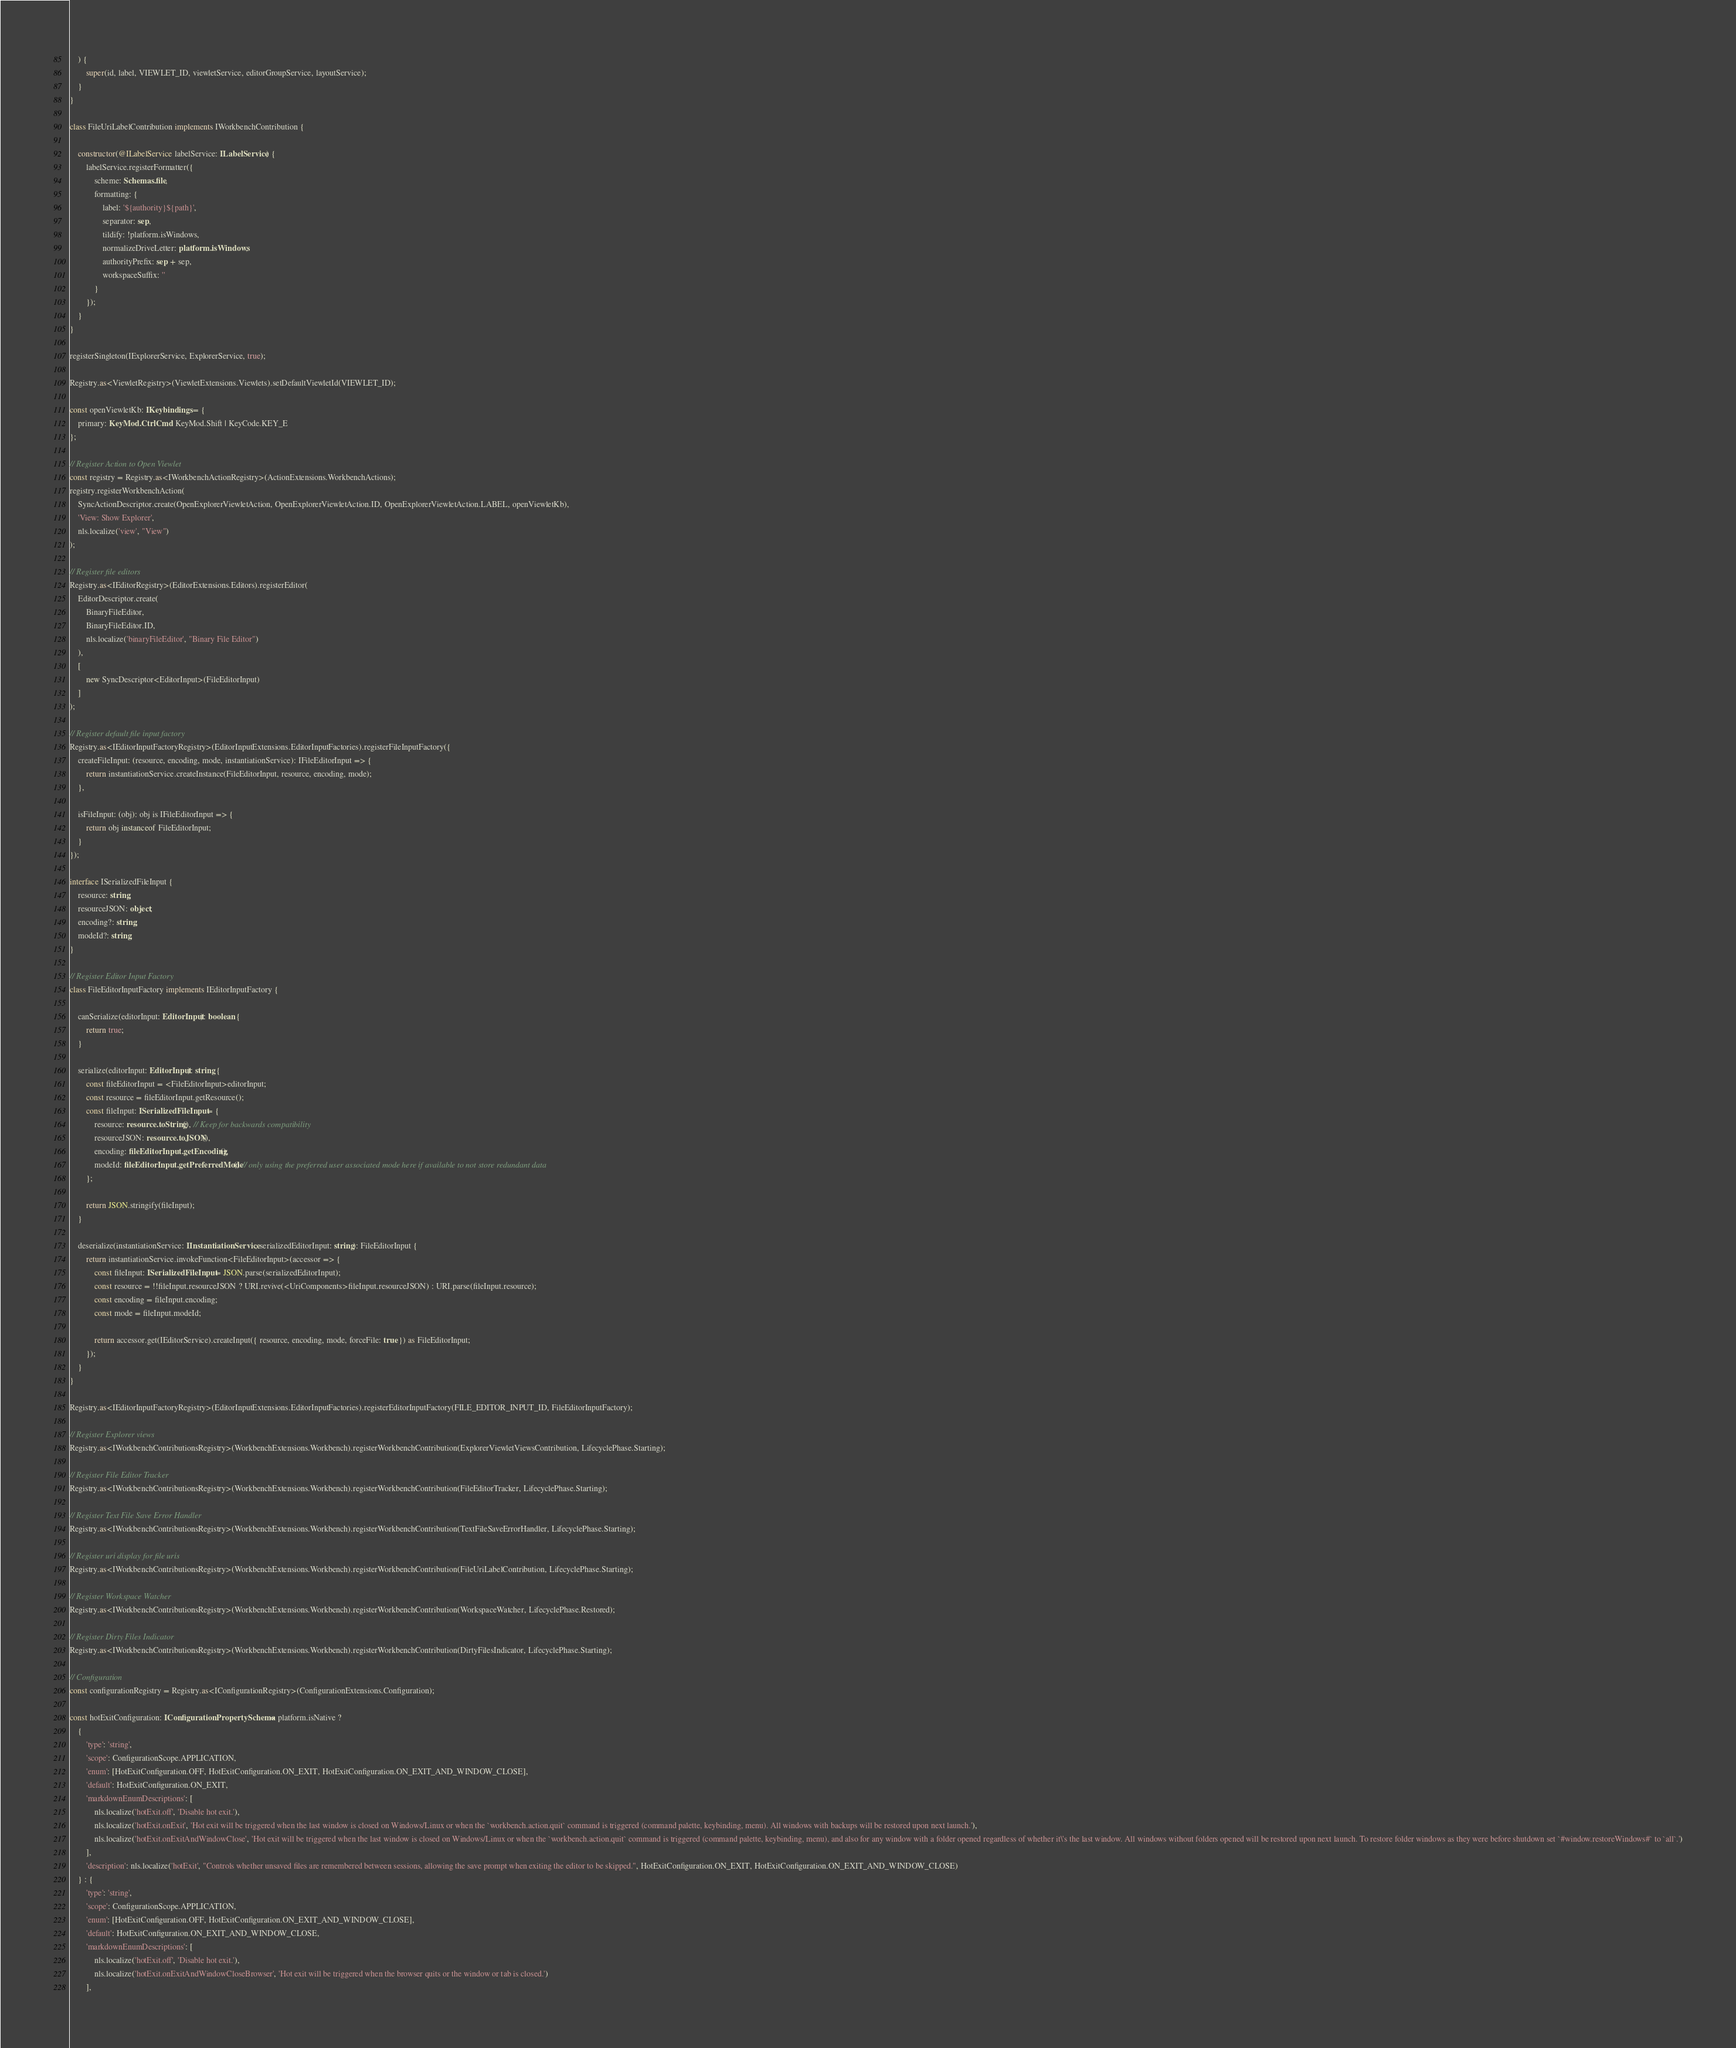Convert code to text. <code><loc_0><loc_0><loc_500><loc_500><_TypeScript_>	) {
		super(id, label, VIEWLET_ID, viewletService, editorGroupService, layoutService);
	}
}

class FileUriLabelContribution implements IWorkbenchContribution {

	constructor(@ILabelService labelService: ILabelService) {
		labelService.registerFormatter({
			scheme: Schemas.file,
			formatting: {
				label: '${authority}${path}',
				separator: sep,
				tildify: !platform.isWindows,
				normalizeDriveLetter: platform.isWindows,
				authorityPrefix: sep + sep,
				workspaceSuffix: ''
			}
		});
	}
}

registerSingleton(IExplorerService, ExplorerService, true);

Registry.as<ViewletRegistry>(ViewletExtensions.Viewlets).setDefaultViewletId(VIEWLET_ID);

const openViewletKb: IKeybindings = {
	primary: KeyMod.CtrlCmd | KeyMod.Shift | KeyCode.KEY_E
};

// Register Action to Open Viewlet
const registry = Registry.as<IWorkbenchActionRegistry>(ActionExtensions.WorkbenchActions);
registry.registerWorkbenchAction(
	SyncActionDescriptor.create(OpenExplorerViewletAction, OpenExplorerViewletAction.ID, OpenExplorerViewletAction.LABEL, openViewletKb),
	'View: Show Explorer',
	nls.localize('view', "View")
);

// Register file editors
Registry.as<IEditorRegistry>(EditorExtensions.Editors).registerEditor(
	EditorDescriptor.create(
		BinaryFileEditor,
		BinaryFileEditor.ID,
		nls.localize('binaryFileEditor', "Binary File Editor")
	),
	[
		new SyncDescriptor<EditorInput>(FileEditorInput)
	]
);

// Register default file input factory
Registry.as<IEditorInputFactoryRegistry>(EditorInputExtensions.EditorInputFactories).registerFileInputFactory({
	createFileInput: (resource, encoding, mode, instantiationService): IFileEditorInput => {
		return instantiationService.createInstance(FileEditorInput, resource, encoding, mode);
	},

	isFileInput: (obj): obj is IFileEditorInput => {
		return obj instanceof FileEditorInput;
	}
});

interface ISerializedFileInput {
	resource: string;
	resourceJSON: object;
	encoding?: string;
	modeId?: string;
}

// Register Editor Input Factory
class FileEditorInputFactory implements IEditorInputFactory {

	canSerialize(editorInput: EditorInput): boolean {
		return true;
	}

	serialize(editorInput: EditorInput): string {
		const fileEditorInput = <FileEditorInput>editorInput;
		const resource = fileEditorInput.getResource();
		const fileInput: ISerializedFileInput = {
			resource: resource.toString(), // Keep for backwards compatibility
			resourceJSON: resource.toJSON(),
			encoding: fileEditorInput.getEncoding(),
			modeId: fileEditorInput.getPreferredMode() // only using the preferred user associated mode here if available to not store redundant data
		};

		return JSON.stringify(fileInput);
	}

	deserialize(instantiationService: IInstantiationService, serializedEditorInput: string): FileEditorInput {
		return instantiationService.invokeFunction<FileEditorInput>(accessor => {
			const fileInput: ISerializedFileInput = JSON.parse(serializedEditorInput);
			const resource = !!fileInput.resourceJSON ? URI.revive(<UriComponents>fileInput.resourceJSON) : URI.parse(fileInput.resource);
			const encoding = fileInput.encoding;
			const mode = fileInput.modeId;

			return accessor.get(IEditorService).createInput({ resource, encoding, mode, forceFile: true }) as FileEditorInput;
		});
	}
}

Registry.as<IEditorInputFactoryRegistry>(EditorInputExtensions.EditorInputFactories).registerEditorInputFactory(FILE_EDITOR_INPUT_ID, FileEditorInputFactory);

// Register Explorer views
Registry.as<IWorkbenchContributionsRegistry>(WorkbenchExtensions.Workbench).registerWorkbenchContribution(ExplorerViewletViewsContribution, LifecyclePhase.Starting);

// Register File Editor Tracker
Registry.as<IWorkbenchContributionsRegistry>(WorkbenchExtensions.Workbench).registerWorkbenchContribution(FileEditorTracker, LifecyclePhase.Starting);

// Register Text File Save Error Handler
Registry.as<IWorkbenchContributionsRegistry>(WorkbenchExtensions.Workbench).registerWorkbenchContribution(TextFileSaveErrorHandler, LifecyclePhase.Starting);

// Register uri display for file uris
Registry.as<IWorkbenchContributionsRegistry>(WorkbenchExtensions.Workbench).registerWorkbenchContribution(FileUriLabelContribution, LifecyclePhase.Starting);

// Register Workspace Watcher
Registry.as<IWorkbenchContributionsRegistry>(WorkbenchExtensions.Workbench).registerWorkbenchContribution(WorkspaceWatcher, LifecyclePhase.Restored);

// Register Dirty Files Indicator
Registry.as<IWorkbenchContributionsRegistry>(WorkbenchExtensions.Workbench).registerWorkbenchContribution(DirtyFilesIndicator, LifecyclePhase.Starting);

// Configuration
const configurationRegistry = Registry.as<IConfigurationRegistry>(ConfigurationExtensions.Configuration);

const hotExitConfiguration: IConfigurationPropertySchema = platform.isNative ?
	{
		'type': 'string',
		'scope': ConfigurationScope.APPLICATION,
		'enum': [HotExitConfiguration.OFF, HotExitConfiguration.ON_EXIT, HotExitConfiguration.ON_EXIT_AND_WINDOW_CLOSE],
		'default': HotExitConfiguration.ON_EXIT,
		'markdownEnumDescriptions': [
			nls.localize('hotExit.off', 'Disable hot exit.'),
			nls.localize('hotExit.onExit', 'Hot exit will be triggered when the last window is closed on Windows/Linux or when the `workbench.action.quit` command is triggered (command palette, keybinding, menu). All windows with backups will be restored upon next launch.'),
			nls.localize('hotExit.onExitAndWindowClose', 'Hot exit will be triggered when the last window is closed on Windows/Linux or when the `workbench.action.quit` command is triggered (command palette, keybinding, menu), and also for any window with a folder opened regardless of whether it\'s the last window. All windows without folders opened will be restored upon next launch. To restore folder windows as they were before shutdown set `#window.restoreWindows#` to `all`.')
		],
		'description': nls.localize('hotExit', "Controls whether unsaved files are remembered between sessions, allowing the save prompt when exiting the editor to be skipped.", HotExitConfiguration.ON_EXIT, HotExitConfiguration.ON_EXIT_AND_WINDOW_CLOSE)
	} : {
		'type': 'string',
		'scope': ConfigurationScope.APPLICATION,
		'enum': [HotExitConfiguration.OFF, HotExitConfiguration.ON_EXIT_AND_WINDOW_CLOSE],
		'default': HotExitConfiguration.ON_EXIT_AND_WINDOW_CLOSE,
		'markdownEnumDescriptions': [
			nls.localize('hotExit.off', 'Disable hot exit.'),
			nls.localize('hotExit.onExitAndWindowCloseBrowser', 'Hot exit will be triggered when the browser quits or the window or tab is closed.')
		],</code> 